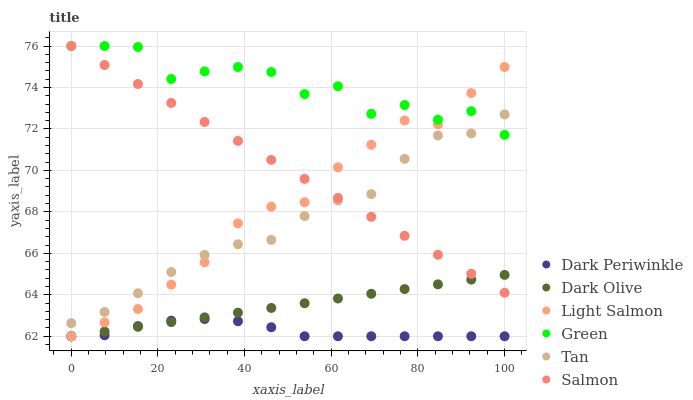Does Dark Periwinkle have the minimum area under the curve?
Answer yes or no. Yes. Does Green have the maximum area under the curve?
Answer yes or no. Yes. Does Dark Olive have the minimum area under the curve?
Answer yes or no. No. Does Dark Olive have the maximum area under the curve?
Answer yes or no. No. Is Dark Olive the smoothest?
Answer yes or no. Yes. Is Green the roughest?
Answer yes or no. Yes. Is Salmon the smoothest?
Answer yes or no. No. Is Salmon the roughest?
Answer yes or no. No. Does Light Salmon have the lowest value?
Answer yes or no. Yes. Does Salmon have the lowest value?
Answer yes or no. No. Does Green have the highest value?
Answer yes or no. Yes. Does Dark Olive have the highest value?
Answer yes or no. No. Is Dark Olive less than Green?
Answer yes or no. Yes. Is Salmon greater than Dark Periwinkle?
Answer yes or no. Yes. Does Salmon intersect Light Salmon?
Answer yes or no. Yes. Is Salmon less than Light Salmon?
Answer yes or no. No. Is Salmon greater than Light Salmon?
Answer yes or no. No. Does Dark Olive intersect Green?
Answer yes or no. No. 